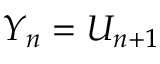Convert formula to latex. <formula><loc_0><loc_0><loc_500><loc_500>Y _ { n } = U _ { n + 1 }</formula> 